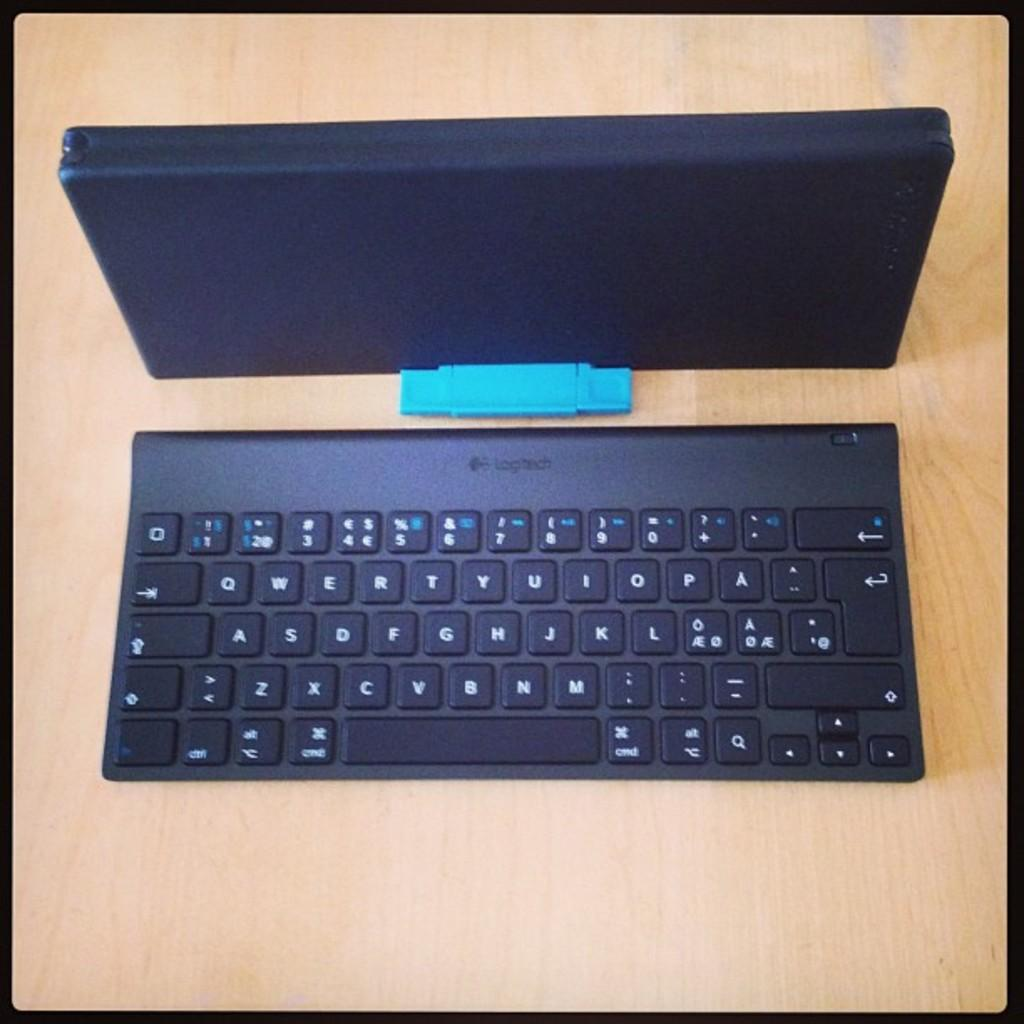What is the primary color of the keyboard in the image? The primary color of the keyboard in the image is black. What color are the letters on the keys of the keyboard? The letters on the keys of the keyboard are white. What is the color of the device next to the keyboard? The device next to the keyboard is also black. What type of surface is visible in the image? The wooden surface is present in the image. What month is depicted on the sheet in the image? There is no sheet present in the image, so it is not possible to determine the month depicted. 